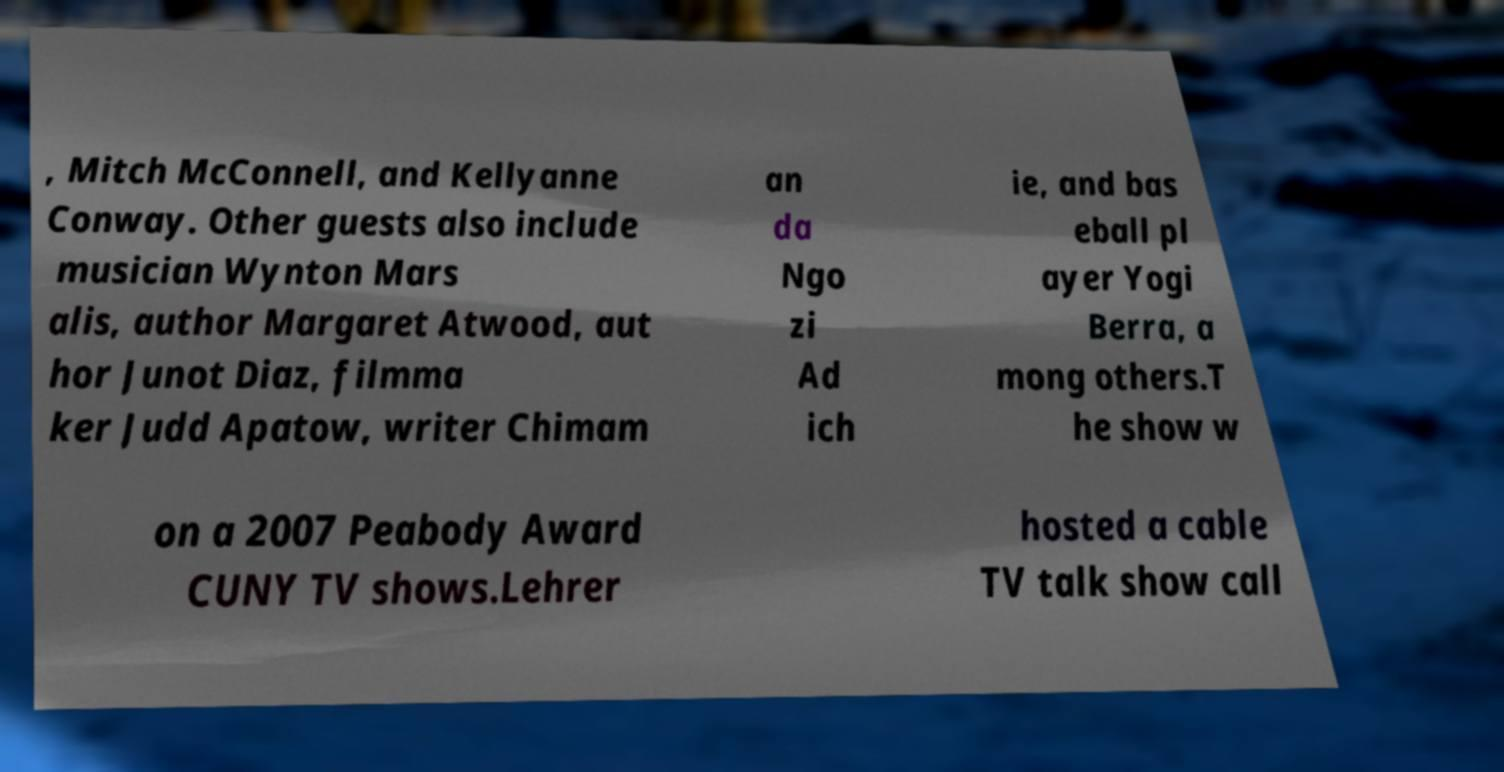Please identify and transcribe the text found in this image. , Mitch McConnell, and Kellyanne Conway. Other guests also include musician Wynton Mars alis, author Margaret Atwood, aut hor Junot Diaz, filmma ker Judd Apatow, writer Chimam an da Ngo zi Ad ich ie, and bas eball pl ayer Yogi Berra, a mong others.T he show w on a 2007 Peabody Award CUNY TV shows.Lehrer hosted a cable TV talk show call 